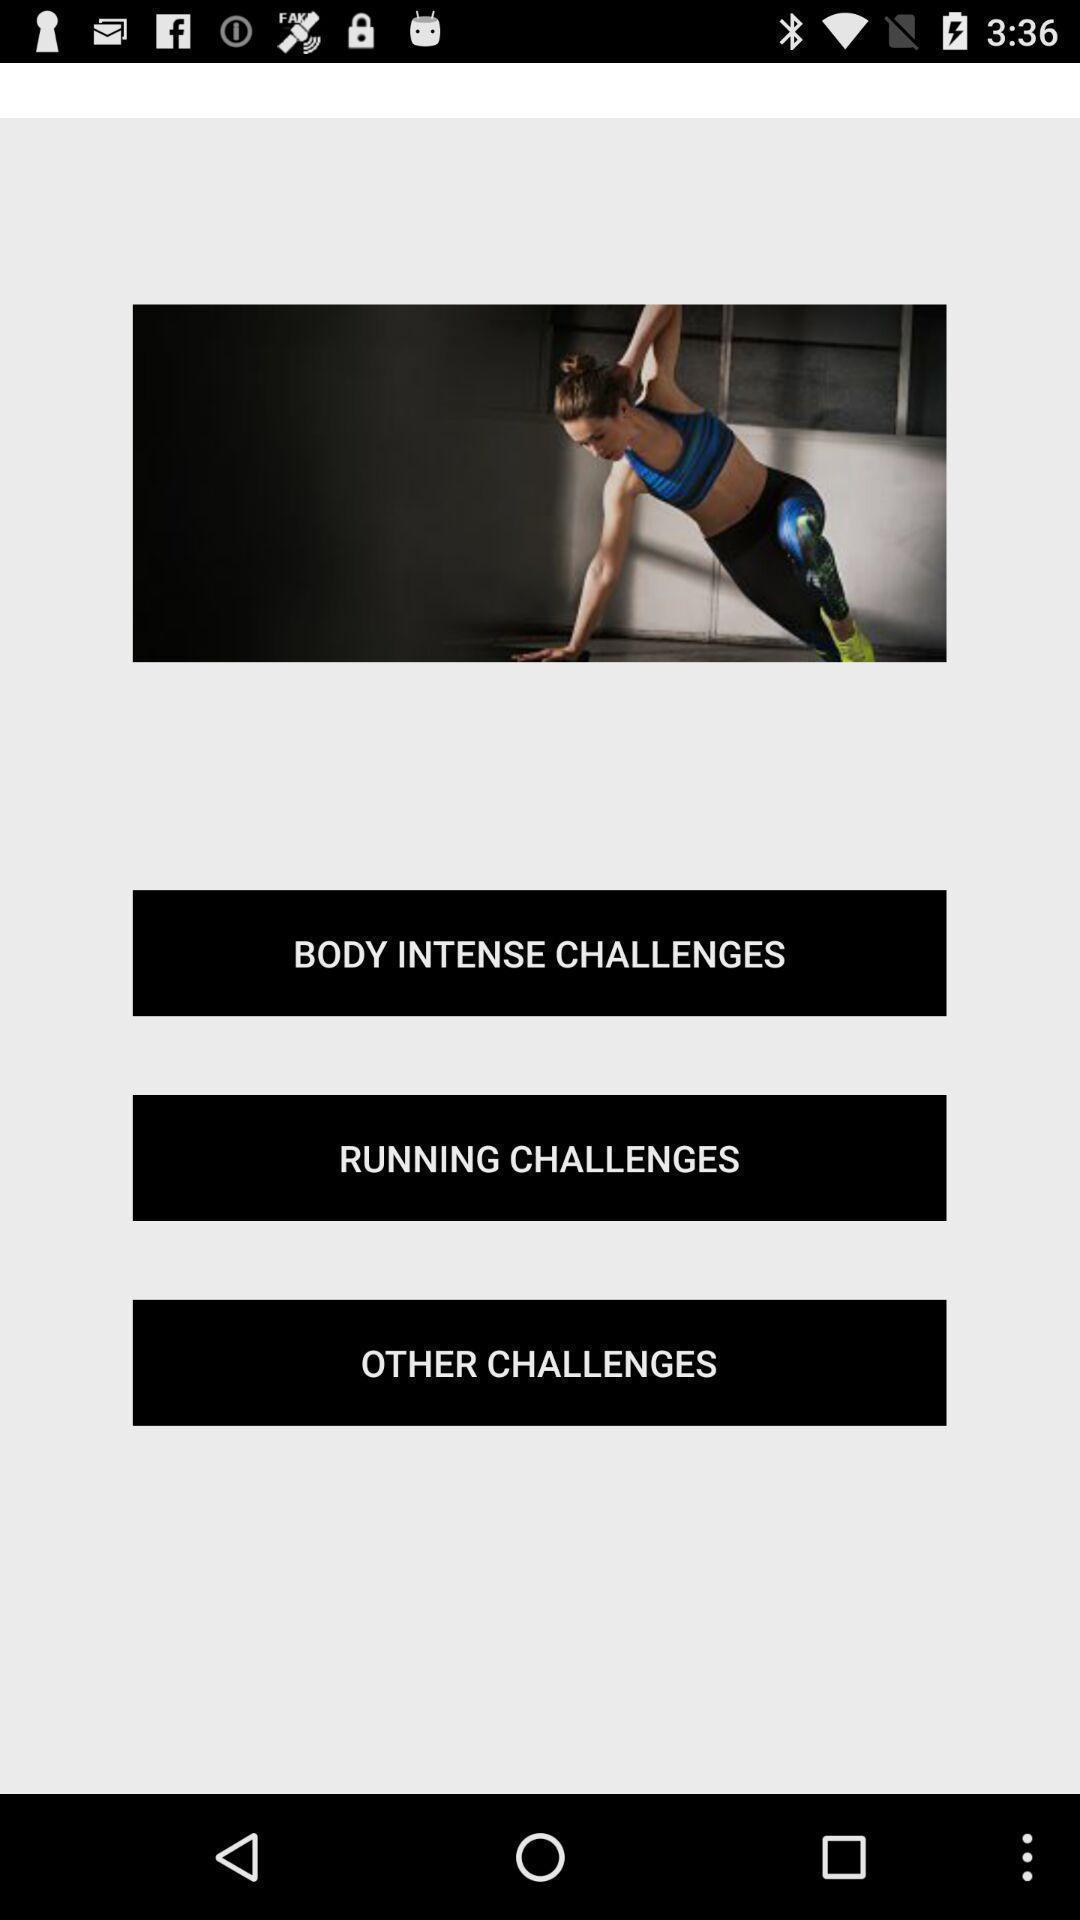Provide a description of this screenshot. Page showing list of exercises in a exercising app. 